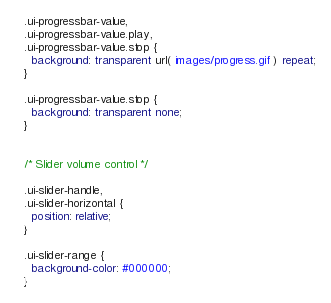Convert code to text. <code><loc_0><loc_0><loc_500><loc_500><_CSS_>.ui-progressbar-value,
.ui-progressbar-value.play,
.ui-progressbar-value.stop {
  background: transparent url( images/progress.gif ) repeat;
}

.ui-progressbar-value.stop {
  background: transparent none;
}


/* Slider volume control */

.ui-slider-handle,
.ui-slider-horizontal {
  position: relative;
}

.ui-slider-range {
  background-color: #000000;
}
</code> 